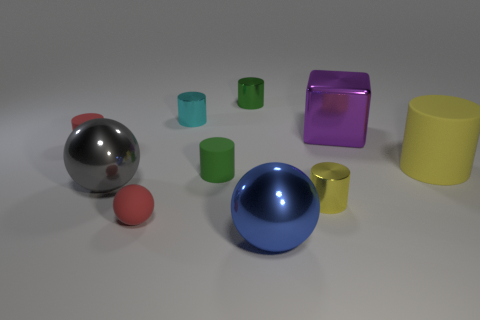Do the yellow thing that is to the left of the large rubber cylinder and the large sphere that is left of the blue ball have the same material? Based on a visual assessment of the image, the large rubber cylinder appears to have a matte finish similar to that of the yellow object to its left, suggesting they could be made of the same or similar material. However, without tactile confirmation or additional information, it is not possible to determine with absolute certainty if the materials are identical. 